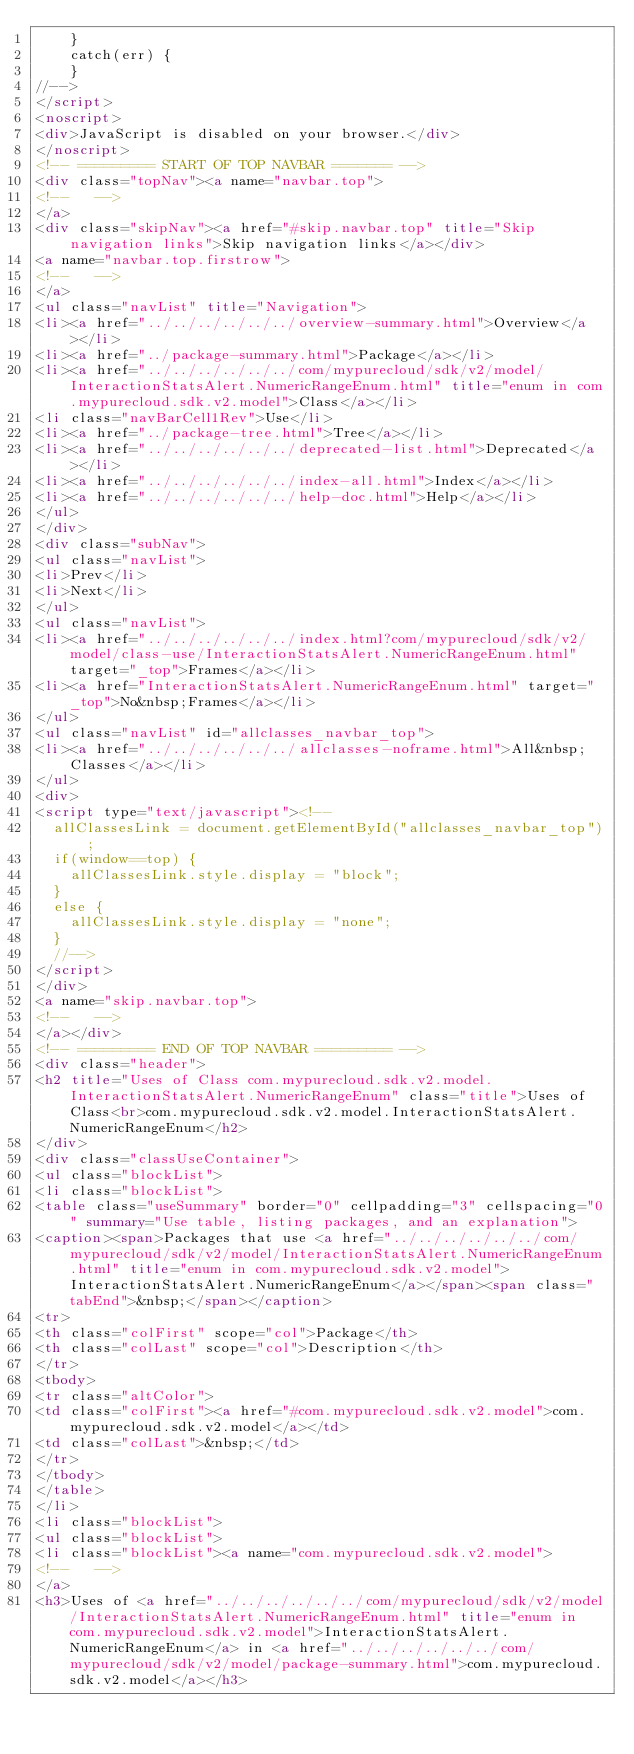Convert code to text. <code><loc_0><loc_0><loc_500><loc_500><_HTML_>    }
    catch(err) {
    }
//-->
</script>
<noscript>
<div>JavaScript is disabled on your browser.</div>
</noscript>
<!-- ========= START OF TOP NAVBAR ======= -->
<div class="topNav"><a name="navbar.top">
<!--   -->
</a>
<div class="skipNav"><a href="#skip.navbar.top" title="Skip navigation links">Skip navigation links</a></div>
<a name="navbar.top.firstrow">
<!--   -->
</a>
<ul class="navList" title="Navigation">
<li><a href="../../../../../../overview-summary.html">Overview</a></li>
<li><a href="../package-summary.html">Package</a></li>
<li><a href="../../../../../../com/mypurecloud/sdk/v2/model/InteractionStatsAlert.NumericRangeEnum.html" title="enum in com.mypurecloud.sdk.v2.model">Class</a></li>
<li class="navBarCell1Rev">Use</li>
<li><a href="../package-tree.html">Tree</a></li>
<li><a href="../../../../../../deprecated-list.html">Deprecated</a></li>
<li><a href="../../../../../../index-all.html">Index</a></li>
<li><a href="../../../../../../help-doc.html">Help</a></li>
</ul>
</div>
<div class="subNav">
<ul class="navList">
<li>Prev</li>
<li>Next</li>
</ul>
<ul class="navList">
<li><a href="../../../../../../index.html?com/mypurecloud/sdk/v2/model/class-use/InteractionStatsAlert.NumericRangeEnum.html" target="_top">Frames</a></li>
<li><a href="InteractionStatsAlert.NumericRangeEnum.html" target="_top">No&nbsp;Frames</a></li>
</ul>
<ul class="navList" id="allclasses_navbar_top">
<li><a href="../../../../../../allclasses-noframe.html">All&nbsp;Classes</a></li>
</ul>
<div>
<script type="text/javascript"><!--
  allClassesLink = document.getElementById("allclasses_navbar_top");
  if(window==top) {
    allClassesLink.style.display = "block";
  }
  else {
    allClassesLink.style.display = "none";
  }
  //-->
</script>
</div>
<a name="skip.navbar.top">
<!--   -->
</a></div>
<!-- ========= END OF TOP NAVBAR ========= -->
<div class="header">
<h2 title="Uses of Class com.mypurecloud.sdk.v2.model.InteractionStatsAlert.NumericRangeEnum" class="title">Uses of Class<br>com.mypurecloud.sdk.v2.model.InteractionStatsAlert.NumericRangeEnum</h2>
</div>
<div class="classUseContainer">
<ul class="blockList">
<li class="blockList">
<table class="useSummary" border="0" cellpadding="3" cellspacing="0" summary="Use table, listing packages, and an explanation">
<caption><span>Packages that use <a href="../../../../../../com/mypurecloud/sdk/v2/model/InteractionStatsAlert.NumericRangeEnum.html" title="enum in com.mypurecloud.sdk.v2.model">InteractionStatsAlert.NumericRangeEnum</a></span><span class="tabEnd">&nbsp;</span></caption>
<tr>
<th class="colFirst" scope="col">Package</th>
<th class="colLast" scope="col">Description</th>
</tr>
<tbody>
<tr class="altColor">
<td class="colFirst"><a href="#com.mypurecloud.sdk.v2.model">com.mypurecloud.sdk.v2.model</a></td>
<td class="colLast">&nbsp;</td>
</tr>
</tbody>
</table>
</li>
<li class="blockList">
<ul class="blockList">
<li class="blockList"><a name="com.mypurecloud.sdk.v2.model">
<!--   -->
</a>
<h3>Uses of <a href="../../../../../../com/mypurecloud/sdk/v2/model/InteractionStatsAlert.NumericRangeEnum.html" title="enum in com.mypurecloud.sdk.v2.model">InteractionStatsAlert.NumericRangeEnum</a> in <a href="../../../../../../com/mypurecloud/sdk/v2/model/package-summary.html">com.mypurecloud.sdk.v2.model</a></h3></code> 